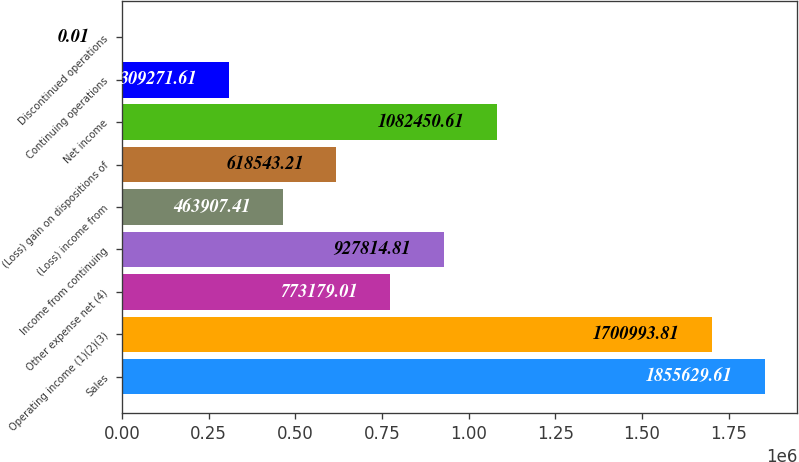<chart> <loc_0><loc_0><loc_500><loc_500><bar_chart><fcel>Sales<fcel>Operating income (1)(2)(3)<fcel>Other expense net (4)<fcel>Income from continuing<fcel>(Loss) income from<fcel>(Loss) gain on dispositions of<fcel>Net income<fcel>Continuing operations<fcel>Discontinued operations<nl><fcel>1.85563e+06<fcel>1.70099e+06<fcel>773179<fcel>927815<fcel>463907<fcel>618543<fcel>1.08245e+06<fcel>309272<fcel>0.01<nl></chart> 